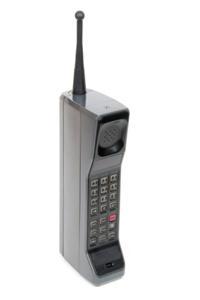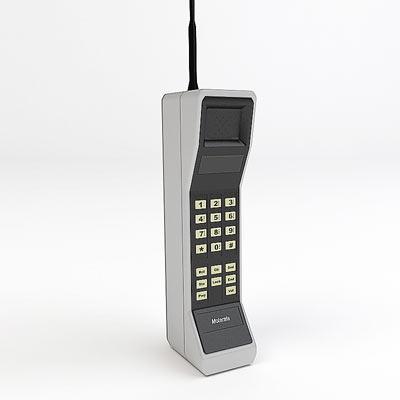The first image is the image on the left, the second image is the image on the right. For the images displayed, is the sentence "The left and right image contains the same number of phones." factually correct? Answer yes or no. Yes. The first image is the image on the left, the second image is the image on the right. For the images displayed, is the sentence "Each image contains only a single phone with an antennae on top and a flat, rectangular base." factually correct? Answer yes or no. Yes. 